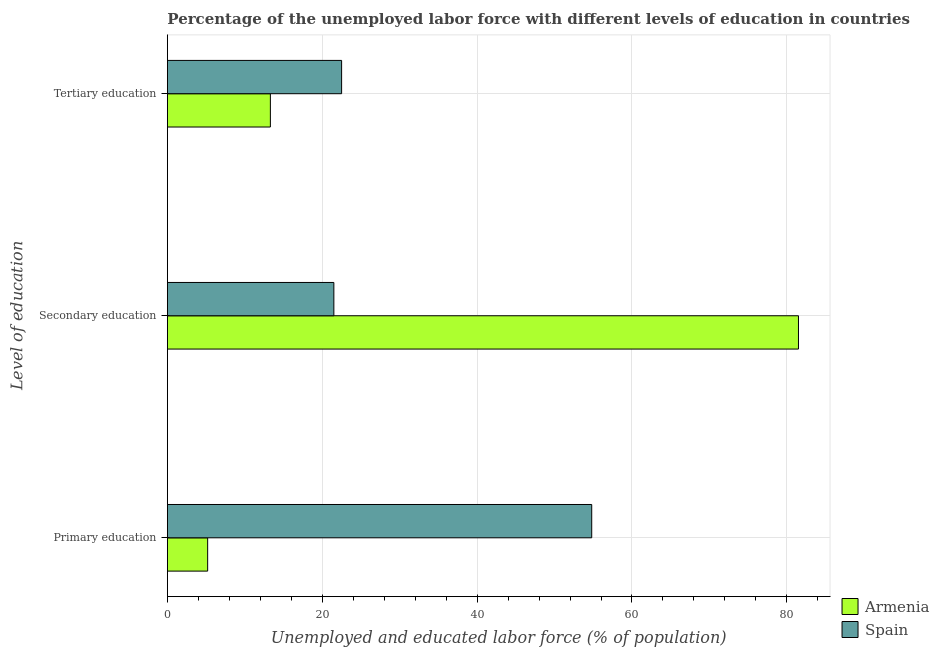What is the label of the 1st group of bars from the top?
Make the answer very short. Tertiary education. What is the percentage of labor force who received secondary education in Spain?
Provide a succinct answer. 21.5. Across all countries, what is the minimum percentage of labor force who received primary education?
Give a very brief answer. 5.2. In which country was the percentage of labor force who received tertiary education minimum?
Offer a terse response. Armenia. What is the total percentage of labor force who received secondary education in the graph?
Ensure brevity in your answer.  103. What is the difference between the percentage of labor force who received primary education in Armenia and that in Spain?
Provide a succinct answer. -49.6. What is the difference between the percentage of labor force who received primary education in Spain and the percentage of labor force who received secondary education in Armenia?
Give a very brief answer. -26.7. What is the average percentage of labor force who received secondary education per country?
Provide a short and direct response. 51.5. What is the difference between the percentage of labor force who received tertiary education and percentage of labor force who received primary education in Spain?
Make the answer very short. -32.3. In how many countries, is the percentage of labor force who received primary education greater than 68 %?
Provide a short and direct response. 0. What is the ratio of the percentage of labor force who received secondary education in Spain to that in Armenia?
Keep it short and to the point. 0.26. What is the difference between the highest and the second highest percentage of labor force who received secondary education?
Provide a succinct answer. 60. In how many countries, is the percentage of labor force who received primary education greater than the average percentage of labor force who received primary education taken over all countries?
Provide a succinct answer. 1. Is the sum of the percentage of labor force who received tertiary education in Armenia and Spain greater than the maximum percentage of labor force who received secondary education across all countries?
Your response must be concise. No. What does the 1st bar from the top in Tertiary education represents?
Your answer should be very brief. Spain. What is the difference between two consecutive major ticks on the X-axis?
Your answer should be very brief. 20. Are the values on the major ticks of X-axis written in scientific E-notation?
Your answer should be very brief. No. Does the graph contain any zero values?
Offer a terse response. No. Does the graph contain grids?
Offer a very short reply. Yes. Where does the legend appear in the graph?
Your answer should be compact. Bottom right. How many legend labels are there?
Keep it short and to the point. 2. What is the title of the graph?
Offer a terse response. Percentage of the unemployed labor force with different levels of education in countries. Does "Small states" appear as one of the legend labels in the graph?
Give a very brief answer. No. What is the label or title of the X-axis?
Your answer should be compact. Unemployed and educated labor force (% of population). What is the label or title of the Y-axis?
Your response must be concise. Level of education. What is the Unemployed and educated labor force (% of population) of Armenia in Primary education?
Provide a succinct answer. 5.2. What is the Unemployed and educated labor force (% of population) of Spain in Primary education?
Keep it short and to the point. 54.8. What is the Unemployed and educated labor force (% of population) of Armenia in Secondary education?
Make the answer very short. 81.5. What is the Unemployed and educated labor force (% of population) in Armenia in Tertiary education?
Your response must be concise. 13.3. Across all Level of education, what is the maximum Unemployed and educated labor force (% of population) in Armenia?
Keep it short and to the point. 81.5. Across all Level of education, what is the maximum Unemployed and educated labor force (% of population) of Spain?
Keep it short and to the point. 54.8. Across all Level of education, what is the minimum Unemployed and educated labor force (% of population) in Armenia?
Your answer should be very brief. 5.2. What is the total Unemployed and educated labor force (% of population) in Armenia in the graph?
Provide a succinct answer. 100. What is the total Unemployed and educated labor force (% of population) in Spain in the graph?
Give a very brief answer. 98.8. What is the difference between the Unemployed and educated labor force (% of population) of Armenia in Primary education and that in Secondary education?
Make the answer very short. -76.3. What is the difference between the Unemployed and educated labor force (% of population) in Spain in Primary education and that in Secondary education?
Provide a short and direct response. 33.3. What is the difference between the Unemployed and educated labor force (% of population) in Armenia in Primary education and that in Tertiary education?
Your answer should be compact. -8.1. What is the difference between the Unemployed and educated labor force (% of population) in Spain in Primary education and that in Tertiary education?
Ensure brevity in your answer.  32.3. What is the difference between the Unemployed and educated labor force (% of population) of Armenia in Secondary education and that in Tertiary education?
Offer a very short reply. 68.2. What is the difference between the Unemployed and educated labor force (% of population) of Spain in Secondary education and that in Tertiary education?
Ensure brevity in your answer.  -1. What is the difference between the Unemployed and educated labor force (% of population) in Armenia in Primary education and the Unemployed and educated labor force (% of population) in Spain in Secondary education?
Provide a short and direct response. -16.3. What is the difference between the Unemployed and educated labor force (% of population) of Armenia in Primary education and the Unemployed and educated labor force (% of population) of Spain in Tertiary education?
Give a very brief answer. -17.3. What is the difference between the Unemployed and educated labor force (% of population) of Armenia in Secondary education and the Unemployed and educated labor force (% of population) of Spain in Tertiary education?
Offer a terse response. 59. What is the average Unemployed and educated labor force (% of population) of Armenia per Level of education?
Ensure brevity in your answer.  33.33. What is the average Unemployed and educated labor force (% of population) in Spain per Level of education?
Give a very brief answer. 32.93. What is the difference between the Unemployed and educated labor force (% of population) in Armenia and Unemployed and educated labor force (% of population) in Spain in Primary education?
Make the answer very short. -49.6. What is the difference between the Unemployed and educated labor force (% of population) of Armenia and Unemployed and educated labor force (% of population) of Spain in Secondary education?
Give a very brief answer. 60. What is the ratio of the Unemployed and educated labor force (% of population) of Armenia in Primary education to that in Secondary education?
Your answer should be very brief. 0.06. What is the ratio of the Unemployed and educated labor force (% of population) of Spain in Primary education to that in Secondary education?
Ensure brevity in your answer.  2.55. What is the ratio of the Unemployed and educated labor force (% of population) of Armenia in Primary education to that in Tertiary education?
Provide a short and direct response. 0.39. What is the ratio of the Unemployed and educated labor force (% of population) of Spain in Primary education to that in Tertiary education?
Your answer should be very brief. 2.44. What is the ratio of the Unemployed and educated labor force (% of population) of Armenia in Secondary education to that in Tertiary education?
Your response must be concise. 6.13. What is the ratio of the Unemployed and educated labor force (% of population) in Spain in Secondary education to that in Tertiary education?
Keep it short and to the point. 0.96. What is the difference between the highest and the second highest Unemployed and educated labor force (% of population) in Armenia?
Your answer should be very brief. 68.2. What is the difference between the highest and the second highest Unemployed and educated labor force (% of population) of Spain?
Ensure brevity in your answer.  32.3. What is the difference between the highest and the lowest Unemployed and educated labor force (% of population) in Armenia?
Your response must be concise. 76.3. What is the difference between the highest and the lowest Unemployed and educated labor force (% of population) of Spain?
Provide a short and direct response. 33.3. 